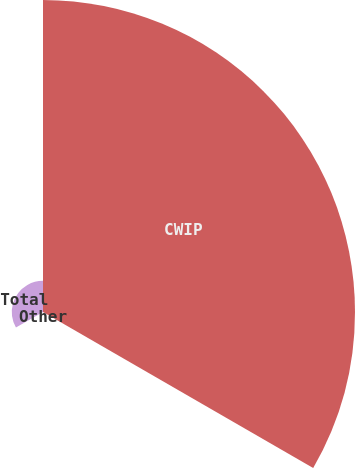<chart> <loc_0><loc_0><loc_500><loc_500><pie_chart><fcel>CWIP<fcel>Other<fcel>Total<nl><fcel>90.88%<fcel>0.02%<fcel>9.1%<nl></chart> 